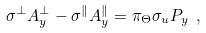<formula> <loc_0><loc_0><loc_500><loc_500>\sigma ^ { \perp } A ^ { \perp } _ { y } - \sigma ^ { \| } A ^ { \| } _ { y } = \pi _ { \Theta } \sigma _ { u } P _ { y } \ ,</formula> 